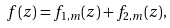<formula> <loc_0><loc_0><loc_500><loc_500>f ( z ) = f _ { 1 , m } ( z ) + f _ { 2 , m } ( z ) ,</formula> 